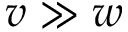Convert formula to latex. <formula><loc_0><loc_0><loc_500><loc_500>v \gg w</formula> 